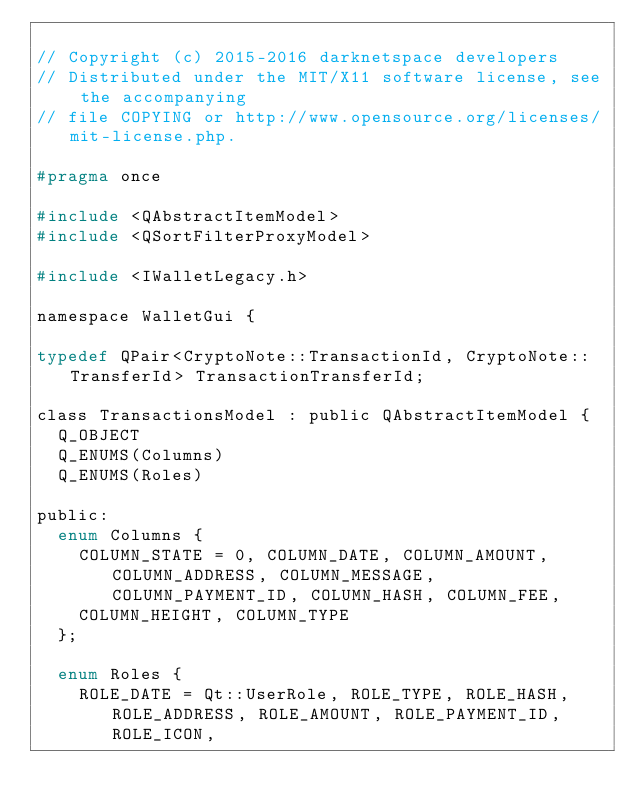Convert code to text. <code><loc_0><loc_0><loc_500><loc_500><_C_>
// Copyright (c) 2015-2016 darknetspace developers
// Distributed under the MIT/X11 software license, see the accompanying
// file COPYING or http://www.opensource.org/licenses/mit-license.php.

#pragma once

#include <QAbstractItemModel>
#include <QSortFilterProxyModel>

#include <IWalletLegacy.h>

namespace WalletGui {

typedef QPair<CryptoNote::TransactionId, CryptoNote::TransferId> TransactionTransferId;

class TransactionsModel : public QAbstractItemModel {
  Q_OBJECT
  Q_ENUMS(Columns)
  Q_ENUMS(Roles)

public:
  enum Columns {
    COLUMN_STATE = 0, COLUMN_DATE, COLUMN_AMOUNT, COLUMN_ADDRESS, COLUMN_MESSAGE, COLUMN_PAYMENT_ID, COLUMN_HASH, COLUMN_FEE,
    COLUMN_HEIGHT, COLUMN_TYPE
  };

  enum Roles {
    ROLE_DATE = Qt::UserRole, ROLE_TYPE, ROLE_HASH, ROLE_ADDRESS, ROLE_AMOUNT, ROLE_PAYMENT_ID, ROLE_ICON,</code> 